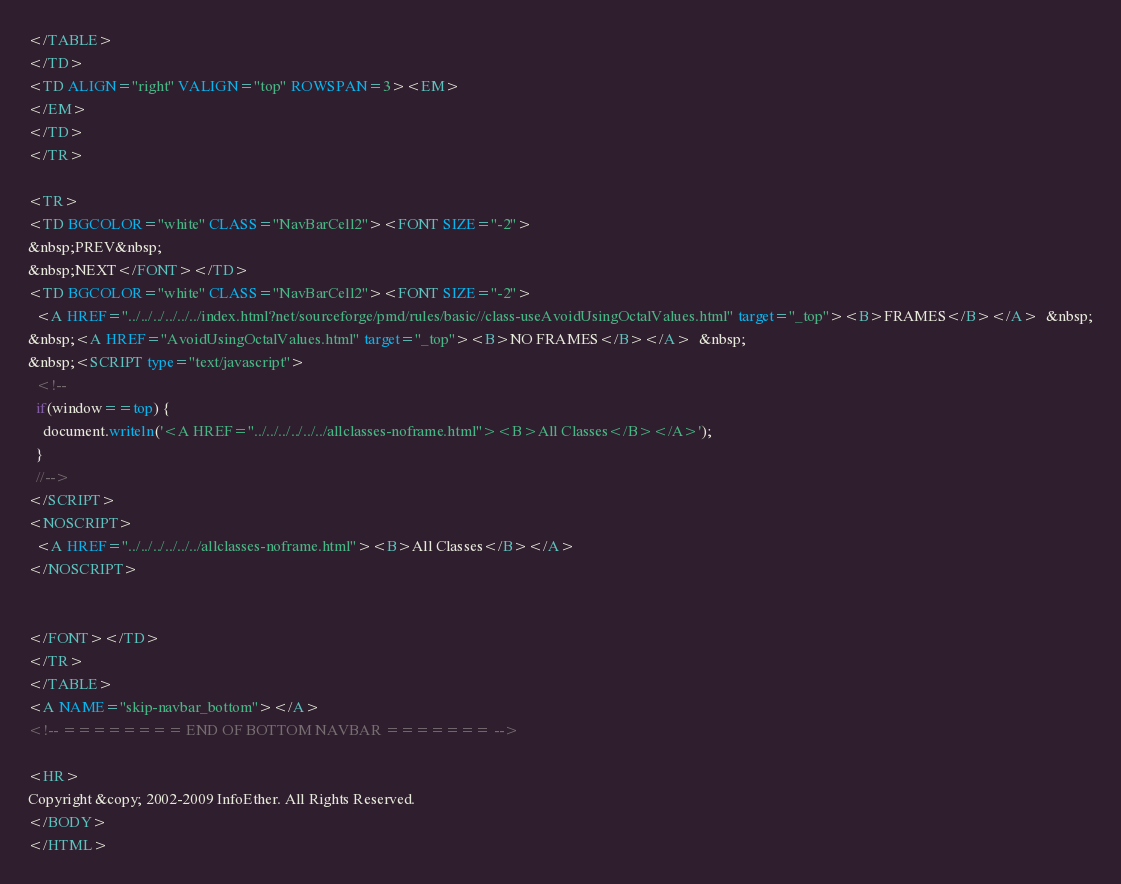<code> <loc_0><loc_0><loc_500><loc_500><_HTML_></TABLE>
</TD>
<TD ALIGN="right" VALIGN="top" ROWSPAN=3><EM>
</EM>
</TD>
</TR>

<TR>
<TD BGCOLOR="white" CLASS="NavBarCell2"><FONT SIZE="-2">
&nbsp;PREV&nbsp;
&nbsp;NEXT</FONT></TD>
<TD BGCOLOR="white" CLASS="NavBarCell2"><FONT SIZE="-2">
  <A HREF="../../../../../../index.html?net/sourceforge/pmd/rules/basic//class-useAvoidUsingOctalValues.html" target="_top"><B>FRAMES</B></A>  &nbsp;
&nbsp;<A HREF="AvoidUsingOctalValues.html" target="_top"><B>NO FRAMES</B></A>  &nbsp;
&nbsp;<SCRIPT type="text/javascript">
  <!--
  if(window==top) {
    document.writeln('<A HREF="../../../../../../allclasses-noframe.html"><B>All Classes</B></A>');
  }
  //-->
</SCRIPT>
<NOSCRIPT>
  <A HREF="../../../../../../allclasses-noframe.html"><B>All Classes</B></A>
</NOSCRIPT>


</FONT></TD>
</TR>
</TABLE>
<A NAME="skip-navbar_bottom"></A>
<!-- ======== END OF BOTTOM NAVBAR ======= -->

<HR>
Copyright &copy; 2002-2009 InfoEther. All Rights Reserved.
</BODY>
</HTML>
</code> 